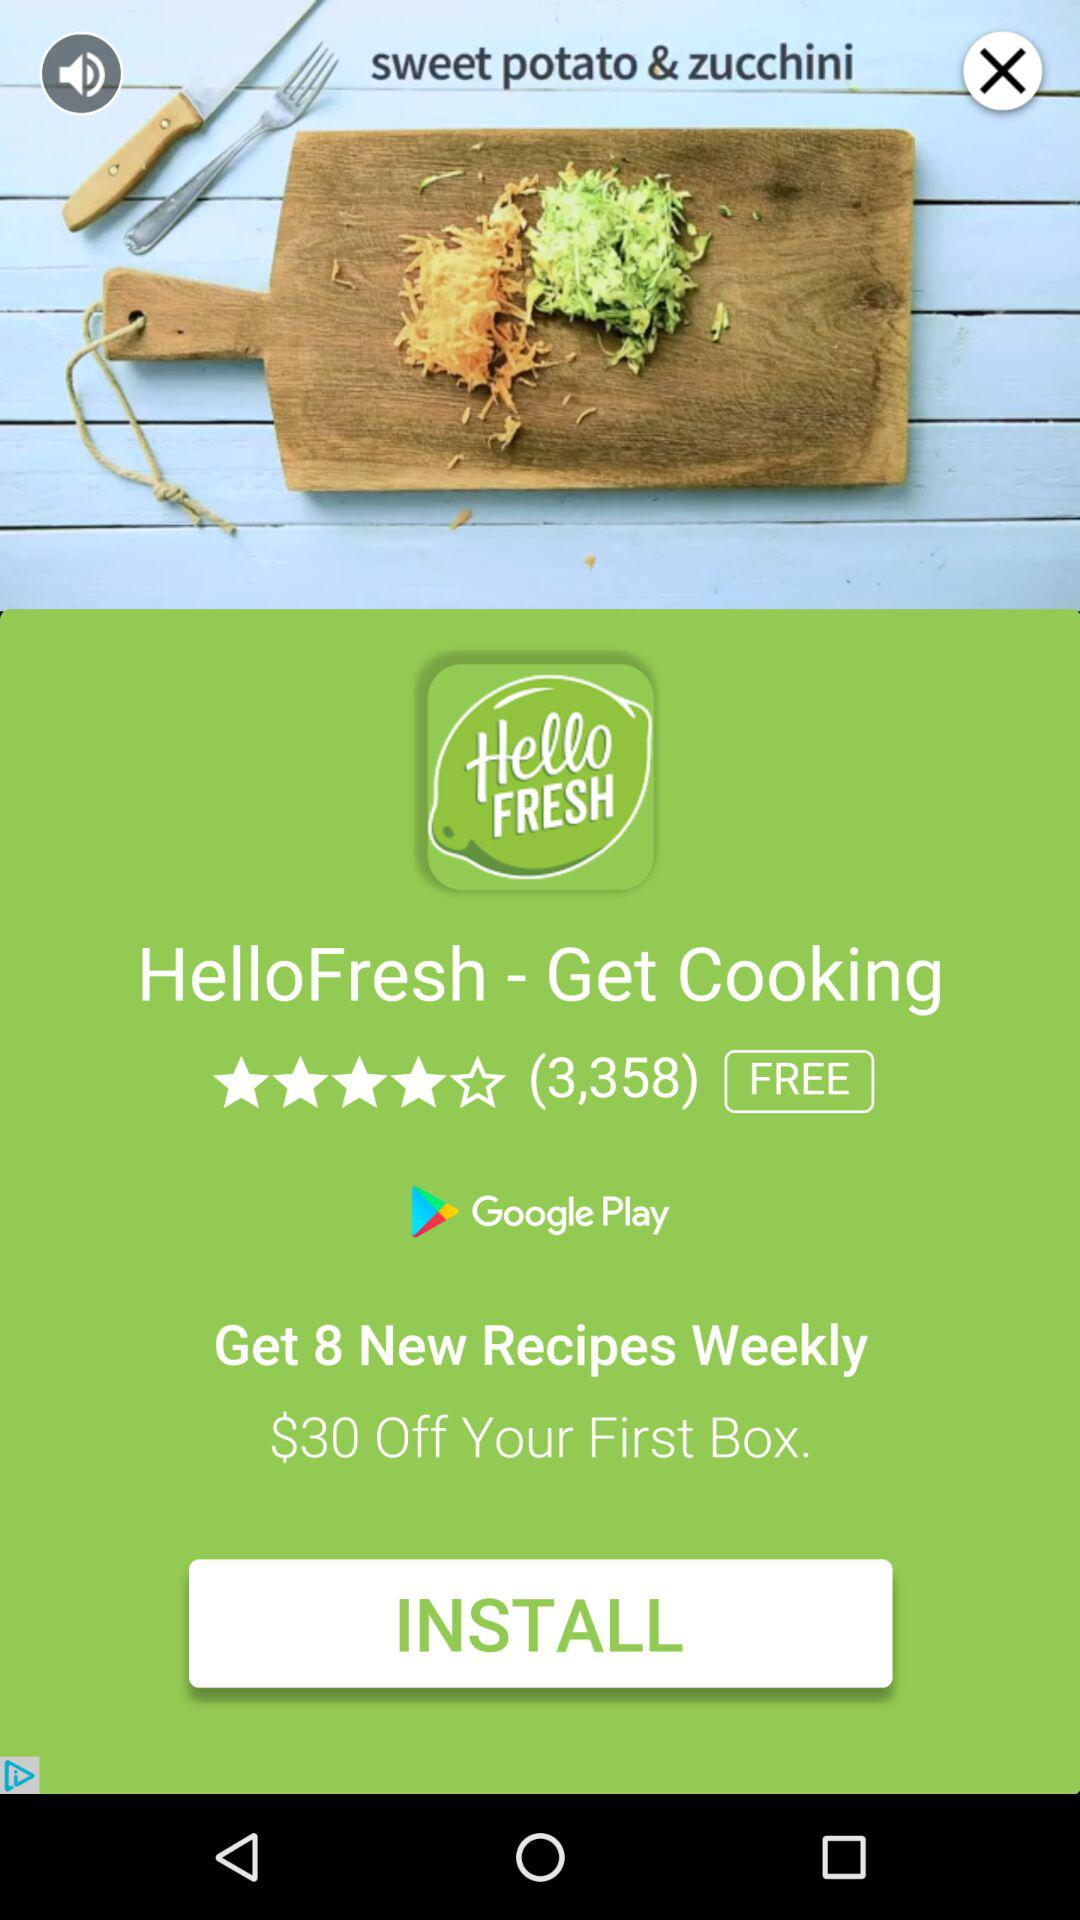How much is the discount on the first box?
Answer the question using a single word or phrase. $30 